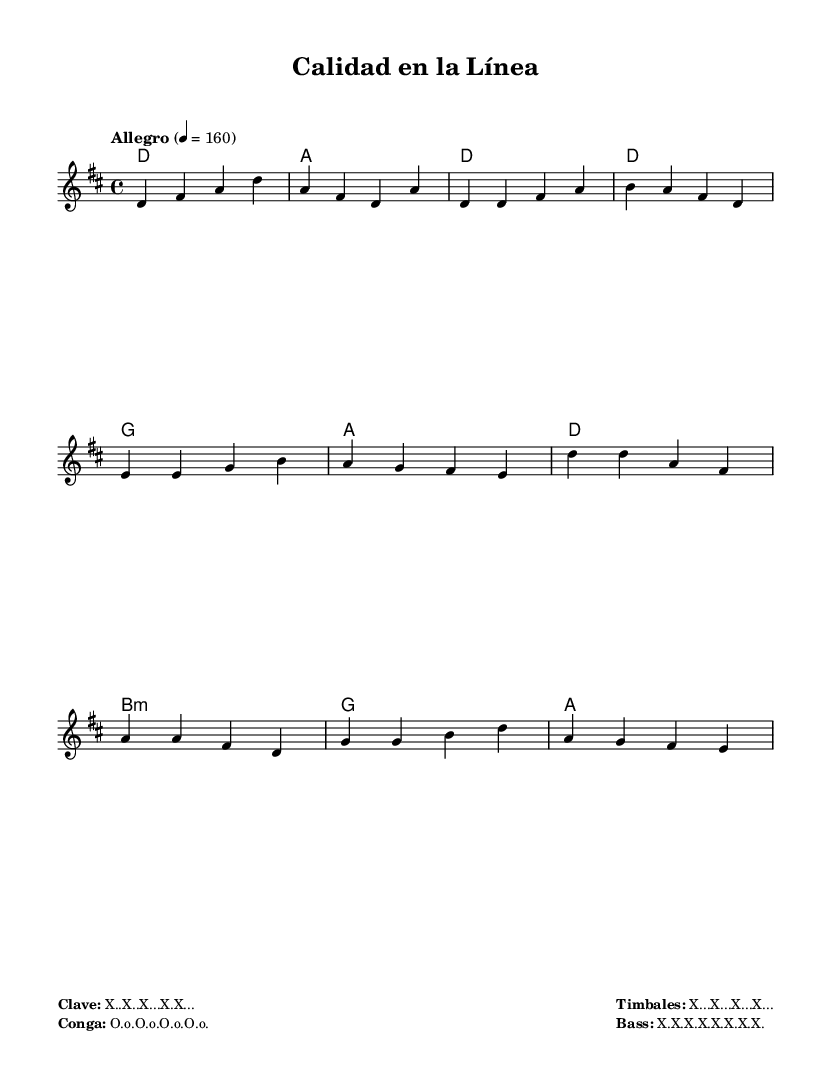What is the key signature of this music? The key signature is D major, which includes two sharps (F# and C#). This can be identified by the key indicated in the header section at the beginning of the score.
Answer: D major What is the time signature of this piece? The time signature is 4/4, which is specified right after the key signature in the score. It indicates that there are four beats in each measure.
Answer: 4/4 What is the tempo marking of this piece? The tempo marking indicates "Allegro" at a speed of 160 beats per minute, as noted in the tempo section at the beginning of the score.
Answer: Allegro, 160 How many measures are in the intro section? The intro section consists of 2 measures, which are represented in the melody where only the introductory notes are played before moving into the verse, as seen in the first two measures.
Answer: 2 measures What is the primary theme described in the lyrics of the verse? The primary theme described in the lyrics focuses on precision and quality in manufacturing, which is evident from the words "Precisión en cada paso, calidad es nuestra meta."
Answer: Precision and quality What is the last chord used in the chorus? The last chord in the chorus is A major, which can be identified in the harmony section where it appears as the final entry after the preceding chords are played in the chorus.
Answer: A What unique Latin rhythmic instruments are mentioned in the markup? The unique Latin rhythmic instruments mentioned include Conga, Timbales, and Bass, which are indicated in the markup section below the sheet music.
Answer: Conga, Timbales, Bass 